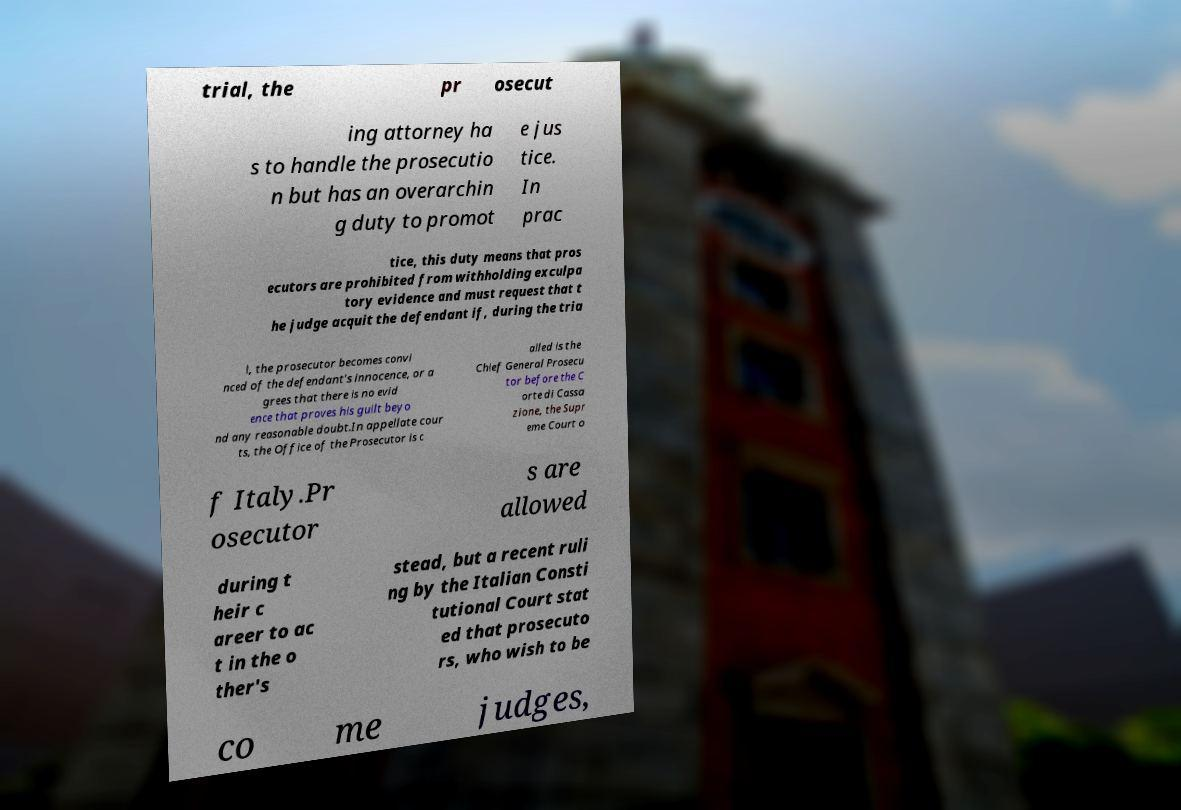Could you extract and type out the text from this image? trial, the pr osecut ing attorney ha s to handle the prosecutio n but has an overarchin g duty to promot e jus tice. In prac tice, this duty means that pros ecutors are prohibited from withholding exculpa tory evidence and must request that t he judge acquit the defendant if, during the tria l, the prosecutor becomes convi nced of the defendant's innocence, or a grees that there is no evid ence that proves his guilt beyo nd any reasonable doubt.In appellate cour ts, the Office of the Prosecutor is c alled is the Chief General Prosecu tor before the C orte di Cassa zione, the Supr eme Court o f Italy.Pr osecutor s are allowed during t heir c areer to ac t in the o ther's stead, but a recent ruli ng by the Italian Consti tutional Court stat ed that prosecuto rs, who wish to be co me judges, 